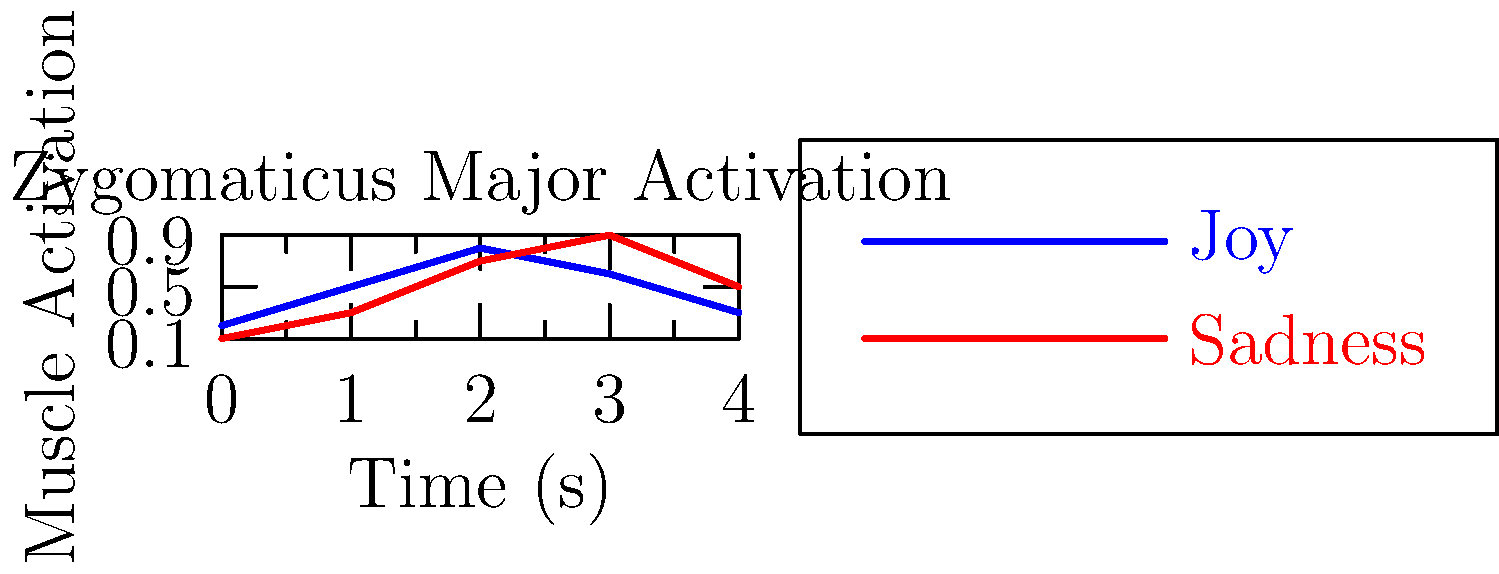In the context of creating emotionally immersive storytelling games, how might the difference in muscle activation patterns between joy and sadness, as shown in the graph for the Zygomaticus Major muscle, influence the design of facial animations for game characters? To answer this question, let's analyze the graph and consider its implications for game character animation:

1. Zygomaticus Major function: This muscle is responsible for raising the corners of the mouth, essential for smiling.

2. Joy activation pattern:
   - Starts low (0.2)
   - Rises quickly to a peak (0.8) at 2 seconds
   - Gradually decreases afterwards

3. Sadness activation pattern:
   - Starts very low (0.1)
   - Rises more slowly
   - Reaches a higher peak (0.9) at 3 seconds
   - Decreases sharply afterwards

4. Implications for character animation:
   a) Timing: Joy expressions should be animated to reach peak faster than sadness.
   b) Intensity: Sadness might involve a more intense activation of this muscle, contrary to what might be expected.
   c) Duration: Joy expressions might be sustained longer, while sadness could have a sharper drop-off.

5. Application in game design:
   - Use these patterns to create more realistic and nuanced facial expressions for characters.
   - Implement a muscle-based animation system that can replicate these activation patterns.
   - Time emotional responses in cutscenes or dialogue to match these activation patterns for increased realism.

6. Enhanced player empathy:
   - More accurate facial expressions can lead to stronger emotional connections between players and game characters.
   - This can result in a more immersive storytelling experience, aligning with the game developer's goals.
Answer: Implement muscle-based animation system mimicking activation patterns: joy (quick rise, gradual fall) and sadness (slow rise, sharp fall) for realistic, nuanced facial expressions, enhancing player empathy and immersion. 